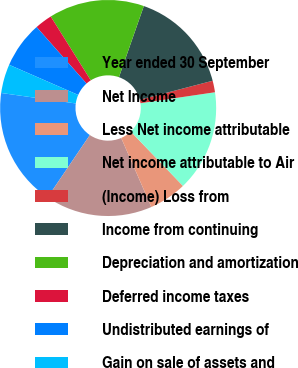Convert chart to OTSL. <chart><loc_0><loc_0><loc_500><loc_500><pie_chart><fcel>Year ended 30 September<fcel>Net Income<fcel>Less Net income attributable<fcel>Net income attributable to Air<fcel>(Income) Loss from<fcel>Income from continuing<fcel>Depreciation and amortization<fcel>Deferred income taxes<fcel>Undistributed earnings of<fcel>Gain on sale of assets and<nl><fcel>17.75%<fcel>16.02%<fcel>5.63%<fcel>15.15%<fcel>1.73%<fcel>15.58%<fcel>14.28%<fcel>2.6%<fcel>6.93%<fcel>4.33%<nl></chart> 